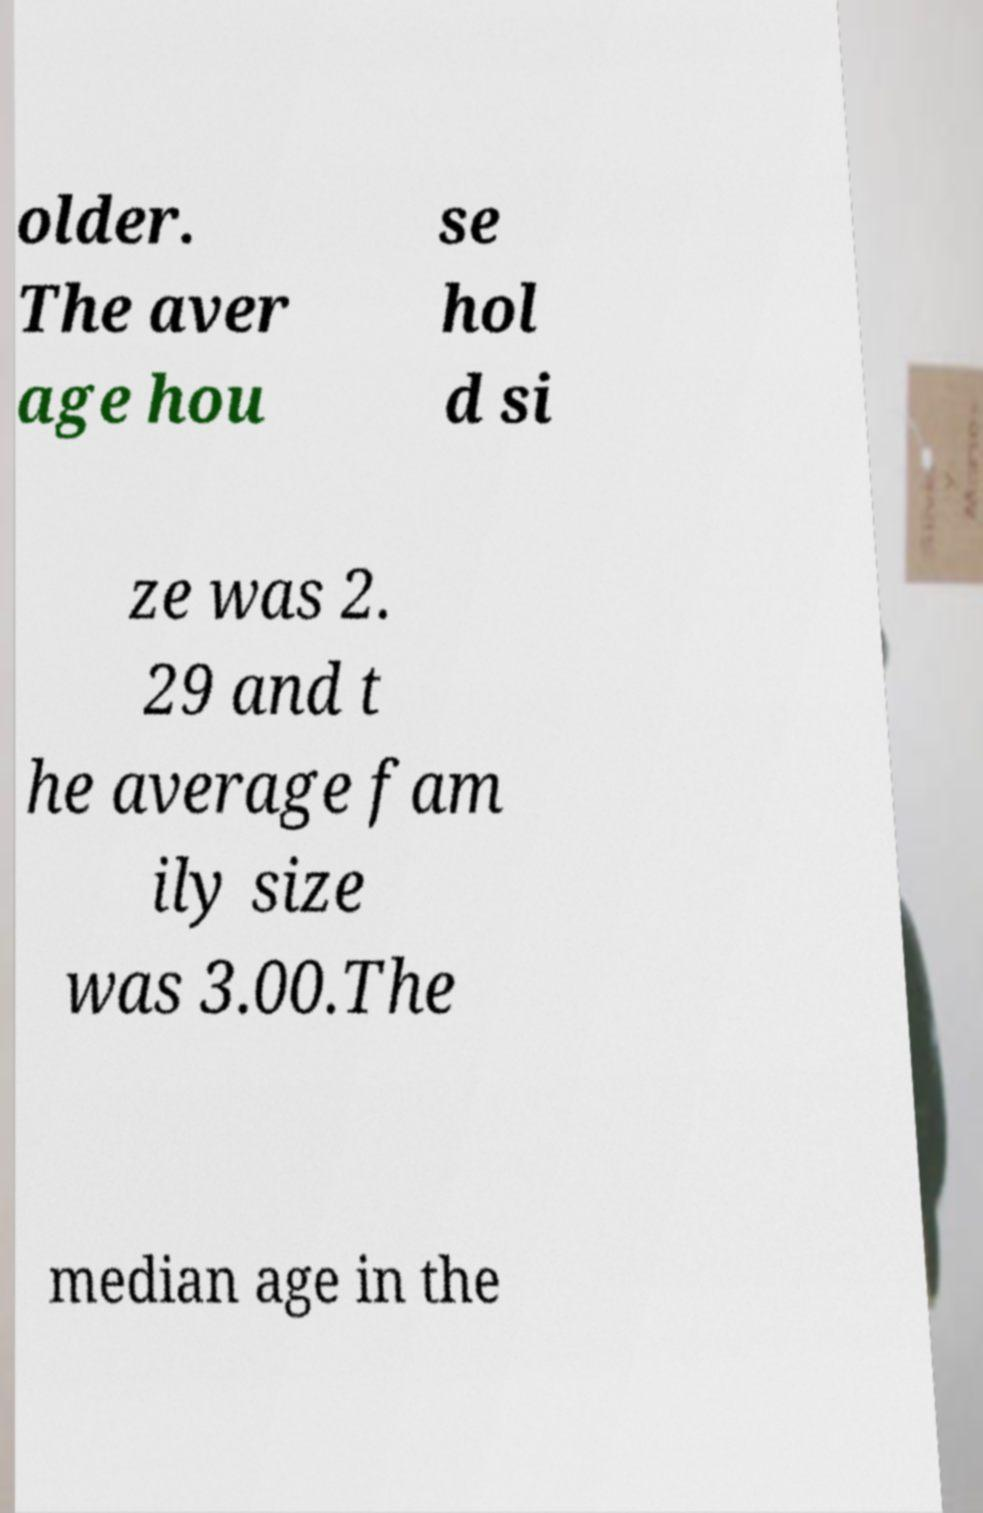Can you accurately transcribe the text from the provided image for me? older. The aver age hou se hol d si ze was 2. 29 and t he average fam ily size was 3.00.The median age in the 